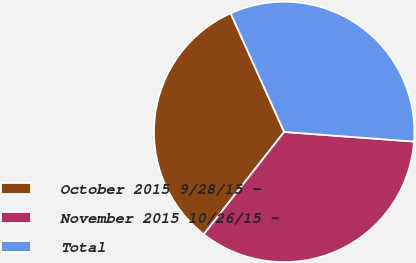<chart> <loc_0><loc_0><loc_500><loc_500><pie_chart><fcel>October 2015 9/28/15 -<fcel>November 2015 10/26/15 -<fcel>Total<nl><fcel>32.66%<fcel>34.42%<fcel>32.92%<nl></chart> 